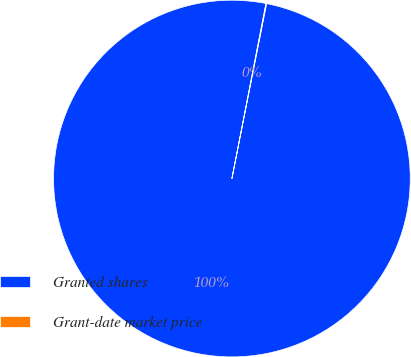Convert chart to OTSL. <chart><loc_0><loc_0><loc_500><loc_500><pie_chart><fcel>Granted shares<fcel>Grant-date market price<nl><fcel>99.94%<fcel>0.06%<nl></chart> 